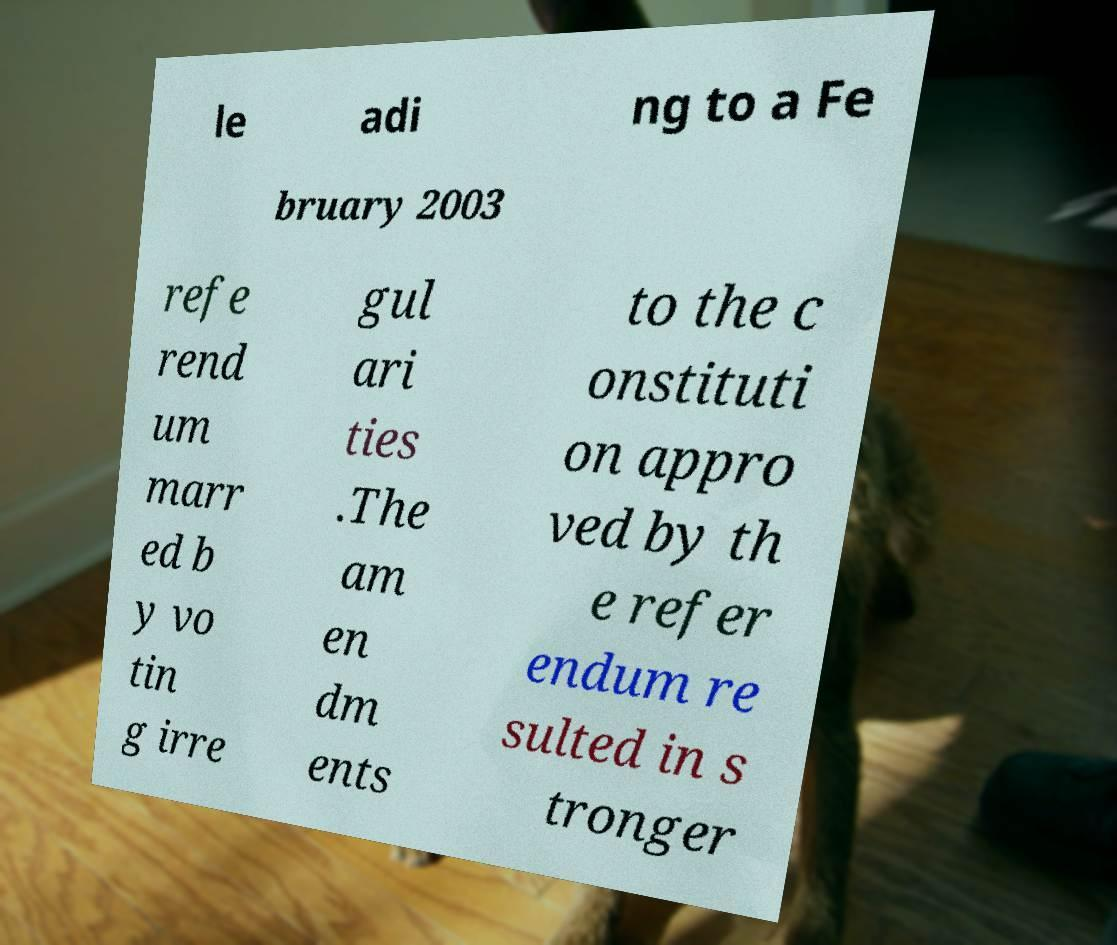For documentation purposes, I need the text within this image transcribed. Could you provide that? le adi ng to a Fe bruary 2003 refe rend um marr ed b y vo tin g irre gul ari ties .The am en dm ents to the c onstituti on appro ved by th e refer endum re sulted in s tronger 